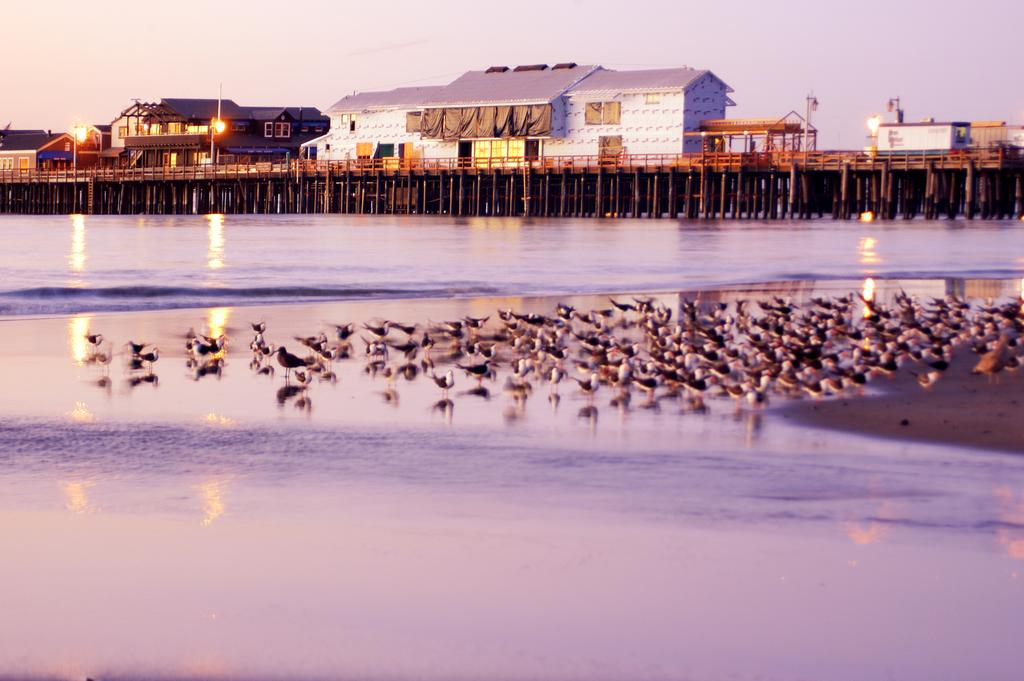What type of animals can be seen in the image? Birds can be seen in the image, both on the water and on the sand. What structures are visible in the background of the image? Houses on a bridge, light poles, windows, and roofs are visible in the background. What part of the natural environment is visible in the birds are in? The birds are on the water and sand, which suggests they are in a coastal or beach area. What is visible in the sky in the background of the image? The sky is visible in the background of the image. How many ladybugs can be seen crawling on the roofs in the image? There are no ladybugs present in the image; it features birds on the water and sand, as well as structures in the background. 